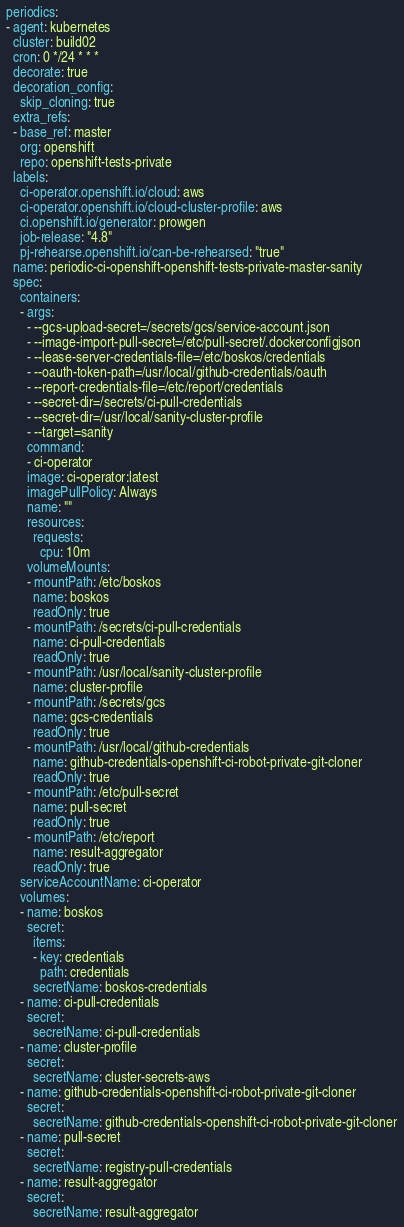<code> <loc_0><loc_0><loc_500><loc_500><_YAML_>periodics:
- agent: kubernetes
  cluster: build02
  cron: 0 */24 * * *
  decorate: true
  decoration_config:
    skip_cloning: true
  extra_refs:
  - base_ref: master
    org: openshift
    repo: openshift-tests-private
  labels:
    ci-operator.openshift.io/cloud: aws
    ci-operator.openshift.io/cloud-cluster-profile: aws
    ci.openshift.io/generator: prowgen
    job-release: "4.8"
    pj-rehearse.openshift.io/can-be-rehearsed: "true"
  name: periodic-ci-openshift-openshift-tests-private-master-sanity
  spec:
    containers:
    - args:
      - --gcs-upload-secret=/secrets/gcs/service-account.json
      - --image-import-pull-secret=/etc/pull-secret/.dockerconfigjson
      - --lease-server-credentials-file=/etc/boskos/credentials
      - --oauth-token-path=/usr/local/github-credentials/oauth
      - --report-credentials-file=/etc/report/credentials
      - --secret-dir=/secrets/ci-pull-credentials
      - --secret-dir=/usr/local/sanity-cluster-profile
      - --target=sanity
      command:
      - ci-operator
      image: ci-operator:latest
      imagePullPolicy: Always
      name: ""
      resources:
        requests:
          cpu: 10m
      volumeMounts:
      - mountPath: /etc/boskos
        name: boskos
        readOnly: true
      - mountPath: /secrets/ci-pull-credentials
        name: ci-pull-credentials
        readOnly: true
      - mountPath: /usr/local/sanity-cluster-profile
        name: cluster-profile
      - mountPath: /secrets/gcs
        name: gcs-credentials
        readOnly: true
      - mountPath: /usr/local/github-credentials
        name: github-credentials-openshift-ci-robot-private-git-cloner
        readOnly: true
      - mountPath: /etc/pull-secret
        name: pull-secret
        readOnly: true
      - mountPath: /etc/report
        name: result-aggregator
        readOnly: true
    serviceAccountName: ci-operator
    volumes:
    - name: boskos
      secret:
        items:
        - key: credentials
          path: credentials
        secretName: boskos-credentials
    - name: ci-pull-credentials
      secret:
        secretName: ci-pull-credentials
    - name: cluster-profile
      secret:
        secretName: cluster-secrets-aws
    - name: github-credentials-openshift-ci-robot-private-git-cloner
      secret:
        secretName: github-credentials-openshift-ci-robot-private-git-cloner
    - name: pull-secret
      secret:
        secretName: registry-pull-credentials
    - name: result-aggregator
      secret:
        secretName: result-aggregator
</code> 